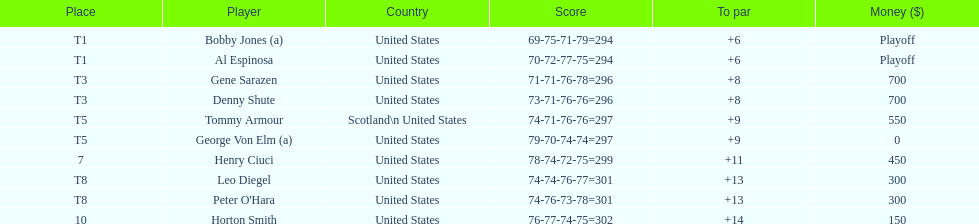Who came in after bobby jones and al espinosa? Gene Sarazen, Denny Shute. 